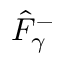<formula> <loc_0><loc_0><loc_500><loc_500>\hat { F } _ { \gamma } ^ { - }</formula> 